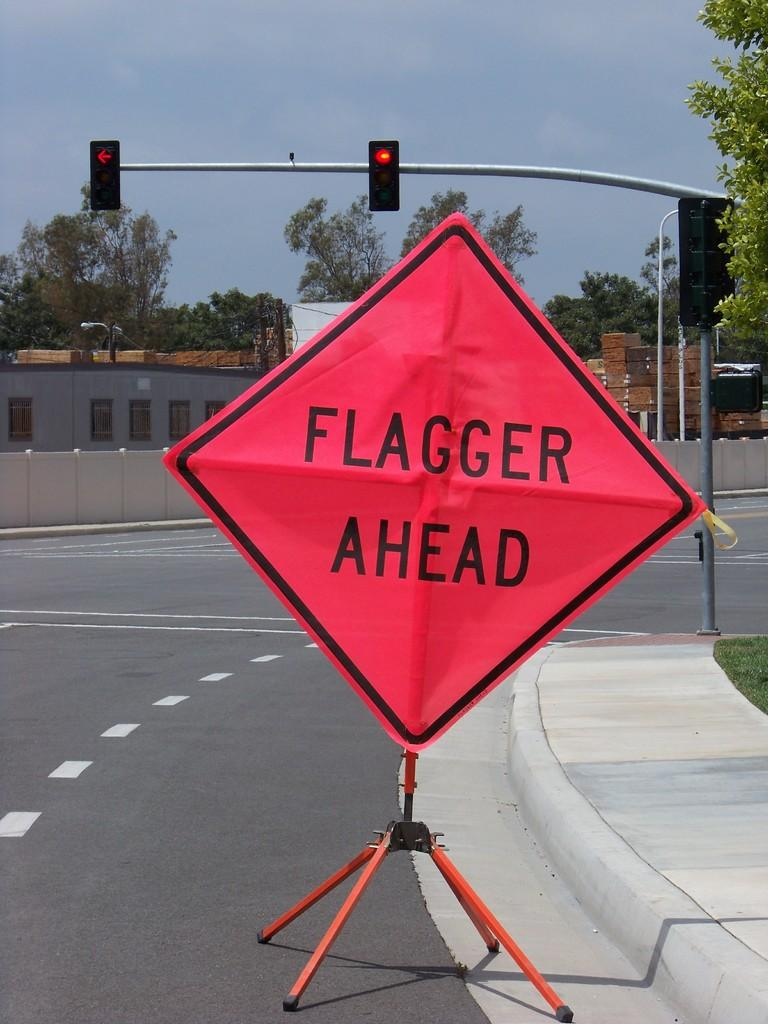Provide a one-sentence caption for the provided image. An orange construction sign reads "flagger ahead" and is set up on a street. 